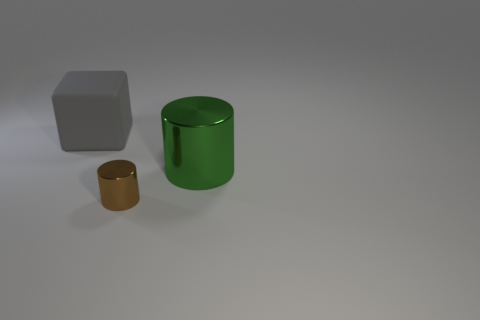There is a big gray cube that is left of the cylinder that is in front of the big thing that is to the right of the small shiny cylinder; what is its material?
Provide a succinct answer. Rubber. How many things are large gray cubes or cyan matte balls?
Keep it short and to the point. 1. Are there any other things that are made of the same material as the green thing?
Offer a very short reply. Yes. The brown metal object is what shape?
Give a very brief answer. Cylinder. The big object that is behind the large object that is in front of the big gray block is what shape?
Provide a succinct answer. Cube. Do the cylinder on the right side of the tiny brown cylinder and the small brown cylinder have the same material?
Make the answer very short. Yes. What number of purple things are either matte cubes or big rubber cylinders?
Offer a very short reply. 0. Are there any tiny shiny cylinders of the same color as the big metal thing?
Make the answer very short. No. Is there a big object that has the same material as the brown cylinder?
Make the answer very short. Yes. There is a object that is behind the tiny metal cylinder and in front of the big gray matte block; what is its shape?
Offer a terse response. Cylinder. 